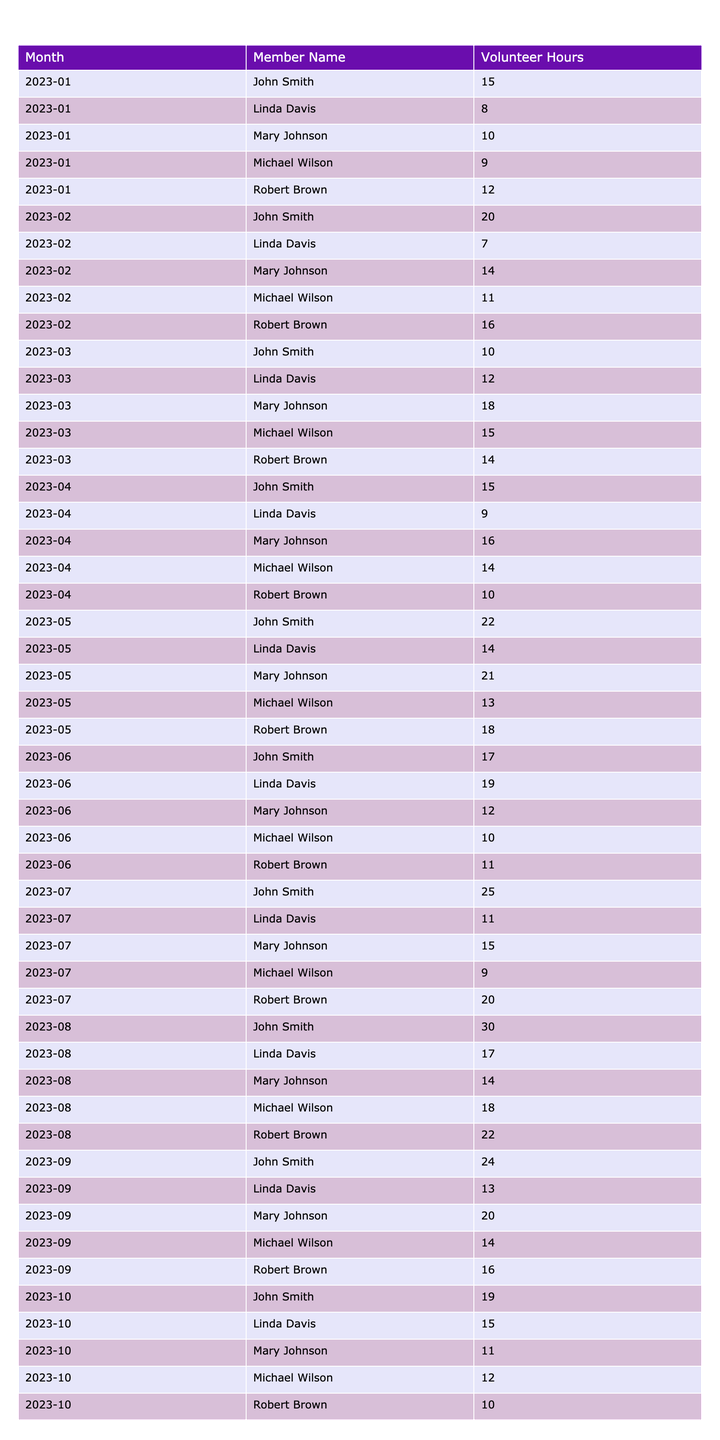What was the total number of volunteer hours logged by John Smith in March 2023? According to the table, John Smith logged 10 hours in March 2023.
Answer: 10 Which board member logged the highest number of volunteer hours in August 2023? The table shows John Smith logged 30 hours in August 2023, which is the highest.
Answer: John Smith What is the average volunteer hours logged by Mary Johnson from January to October 2023? Mary Johnson's hours are 10, 14, 18, 16, 21, 12, 15, 14, 20, and 11; summing these gives  151. There are 10 months, so the average is 151/10 = 15.1.
Answer: 15.1 Did Robert Brown log more than 15 hours in April 2023? In April 2023, Robert Brown logged 10 hours, which is not more than 15.
Answer: No What is the total volunteer hours logged by all members from January to June 2023? First, we sum all the hours from January (15 + 10 + 12 + 8 + 9 = 54) to June (17 + 12 + 11 + 19 + 10 = 69), which gives a total of 54 + 60 + 68 + 62 + 53 + 69 = 326 hours.
Answer: 326 Which month had the least total volunteer hours logged by all members? A comparison of monthly totals shows that February had a total of 68 hours, indicating it was the month with the least volunteer hours logged.
Answer: February How many volunteer hours did Linda Davis log in total from January to October 2023? Linda Davis’s total hours are calculated as follows: 8 + 7 + 12 + 9 + 14 + 19 + 11 + 17 + 13 + 15 = 125.
Answer: 125 Was there a month where every board member logged more than 15 hours? In May 2023, all members logged more than 15 hours, confirming this occurred that month.
Answer: Yes What was the increase in John Smith's logged hours from July to August 2023? John Smith logged 25 hours in July and 30 hours in August. The increase is 30 - 25 = 5 hours.
Answer: 5 Which board member has the most fluctuations in volunteer hours month-over-month? By analyzing the data, Mary Johnson shows variations in her hours, specifically from 10 to 21 in May, indicating she has the most fluctuation.
Answer: Mary Johnson What was the sum of volunteer hours logged by all members in September 2023? The sum of hours logged in September is 24 + 20 + 16 + 13 + 14 = 97 hours in total.
Answer: 97 